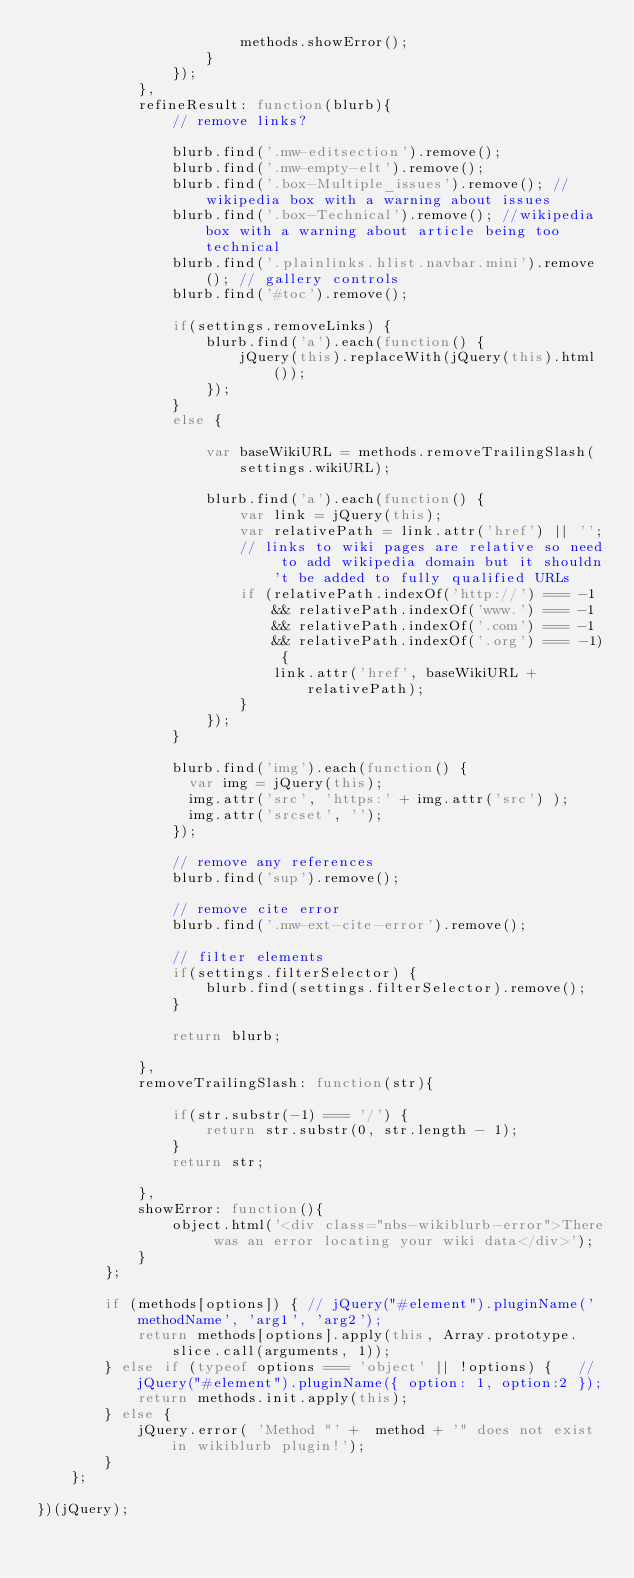<code> <loc_0><loc_0><loc_500><loc_500><_JavaScript_>                        methods.showError();
                    }
                });
            },
            refineResult: function(blurb){
                // remove links?

                blurb.find('.mw-editsection').remove();
                blurb.find('.mw-empty-elt').remove();
                blurb.find('.box-Multiple_issues').remove(); // wikipedia box with a warning about issues
                blurb.find('.box-Technical').remove(); //wikipedia box with a warning about article being too technical
                blurb.find('.plainlinks.hlist.navbar.mini').remove(); // gallery controls
                blurb.find('#toc').remove();

                if(settings.removeLinks) {
                    blurb.find('a').each(function() {
                        jQuery(this).replaceWith(jQuery(this).html());
                    });
                }
                else {

                    var baseWikiURL = methods.removeTrailingSlash(settings.wikiURL);

                    blurb.find('a').each(function() {
                        var link = jQuery(this);
                        var relativePath = link.attr('href') || '';
                        // links to wiki pages are relative so need to add wikipedia domain but it shouldn't be added to fully qualified URLs
                        if (relativePath.indexOf('http://') === -1 && relativePath.indexOf('www.') === -1 && relativePath.indexOf('.com') === -1 && relativePath.indexOf('.org') === -1) {
                            link.attr('href', baseWikiURL + relativePath);
                        }
                    });
                }

                blurb.find('img').each(function() {
                  var img = jQuery(this);
                  img.attr('src', 'https:' + img.attr('src') );
                  img.attr('srcset', '');
                });

                // remove any references
                blurb.find('sup').remove();

                // remove cite error
                blurb.find('.mw-ext-cite-error').remove();

                // filter elements
                if(settings.filterSelector) {
                    blurb.find(settings.filterSelector).remove();
                }

                return blurb;

            },
            removeTrailingSlash: function(str){

                if(str.substr(-1) === '/') {
                    return str.substr(0, str.length - 1);
                }
                return str;

            },
            showError: function(){
                object.html('<div class="nbs-wikiblurb-error">There was an error locating your wiki data</div>');
            }
        };

        if (methods[options]) { // jQuery("#element").pluginName('methodName', 'arg1', 'arg2');
            return methods[options].apply(this, Array.prototype.slice.call(arguments, 1));
        } else if (typeof options === 'object' || !options) { 	// jQuery("#element").pluginName({ option: 1, option:2 });
            return methods.init.apply(this);
        } else {
            jQuery.error( 'Method "' +  method + '" does not exist in wikiblurb plugin!');
        }
    };

})(jQuery);
</code> 